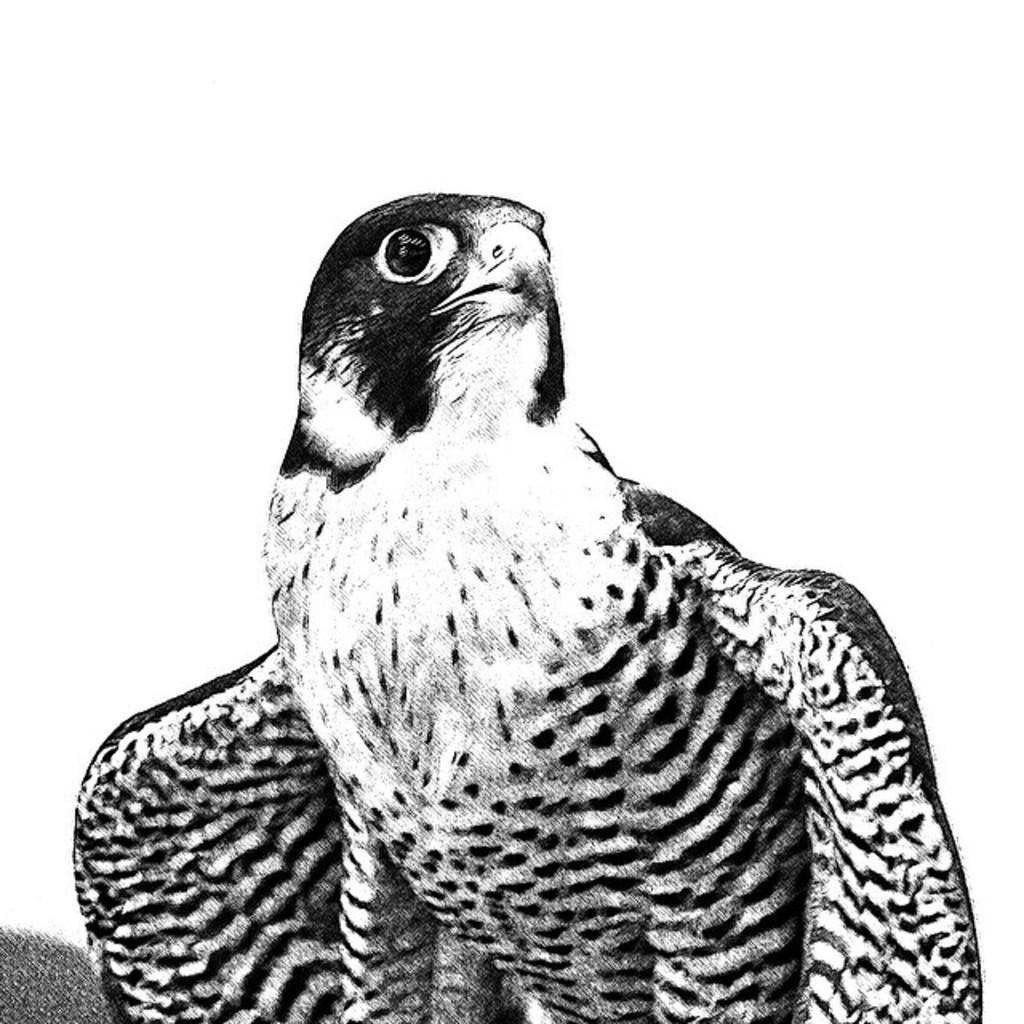What is depicted in the image? There is a sketch of an eagle in the image. What color is the background of the image? The background of the image is white. What type of dinosaurs can be seen in the image? There are no dinosaurs present in the image; it features a sketch of an eagle. What type of business is being conducted in the image? There is no indication of any business activity in the image, as it only contains a sketch of an eagle on a white background. 